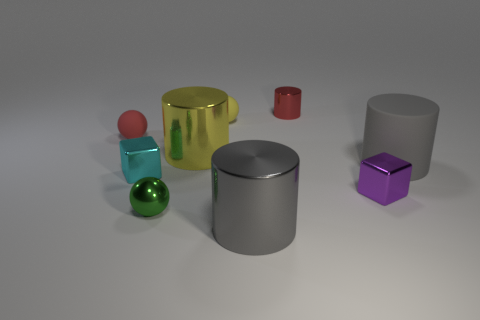What number of small objects are cyan cubes or gray rubber things?
Make the answer very short. 1. There is a metallic cylinder that is the same size as the green thing; what is its color?
Provide a succinct answer. Red. There is a large gray metallic thing; what number of big gray objects are on the right side of it?
Provide a succinct answer. 1. Is there a large cyan object made of the same material as the tiny yellow ball?
Your response must be concise. No. The other object that is the same color as the big matte thing is what shape?
Your answer should be very brief. Cylinder. What is the color of the metallic object in front of the green metallic object?
Provide a short and direct response. Gray. Are there an equal number of big objects in front of the small purple metallic thing and red things that are to the right of the small red cylinder?
Provide a short and direct response. No. The big gray thing that is to the left of the large gray matte cylinder that is behind the cyan block is made of what material?
Keep it short and to the point. Metal. How many things are small green rubber cylinders or big gray objects on the left side of the purple metallic block?
Give a very brief answer. 1. There is a ball that is made of the same material as the large yellow thing; what size is it?
Your response must be concise. Small. 